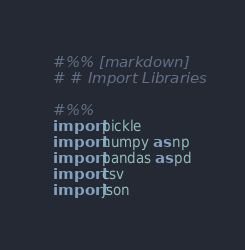<code> <loc_0><loc_0><loc_500><loc_500><_Python_>#%% [markdown]
# # Import Libraries

#%%
import pickle
import numpy as np
import pandas as pd
import csv
import json
</code> 